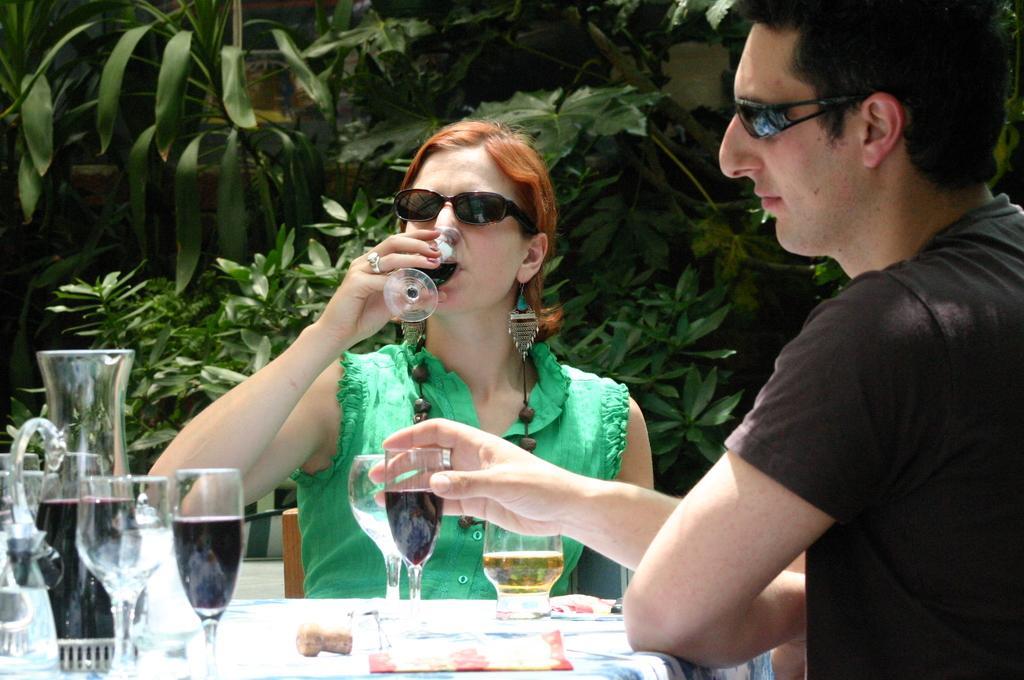How would you summarize this image in a sentence or two? The women wearing green dress is sitting in a chair and drinking wine and the person beside him is holding a glass which is on the table and there are trees in the background. 